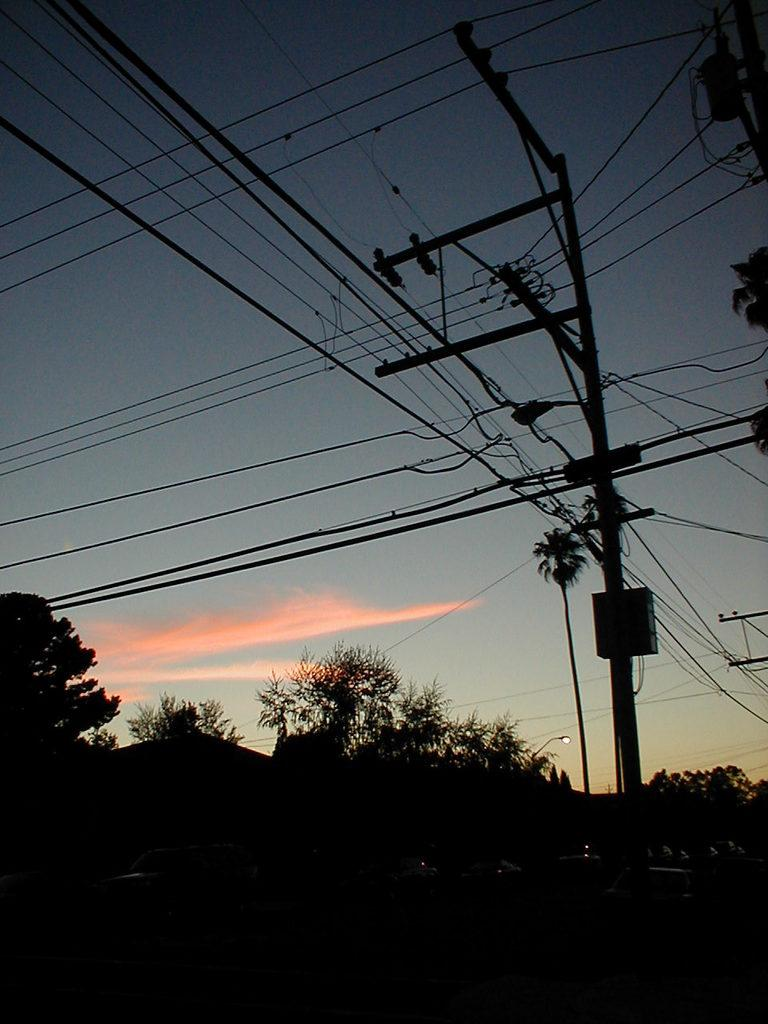What type of natural elements can be seen in the image? There are trees in the image. What type of man-made structures are present in the image? There are buildings in the image. What type of transportation is visible in the image? There are vehicles moving on the road in the image. What type of infrastructure is present in the image? There is an electrical pole in the image, and cables are attached to it. What type of toothbrush is hanging from the electrical pole in the image? There is no toothbrush present in the image; it features trees, buildings, vehicles, and an electrical pole with cables. What type of meal is being prepared on the road in the image? There is no meal being prepared in the image; it shows vehicles moving on the road, along with trees, buildings, and an electrical pole with cables. 